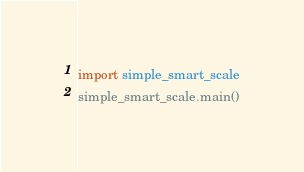<code> <loc_0><loc_0><loc_500><loc_500><_Python_>import simple_smart_scale
simple_smart_scale.main()</code> 